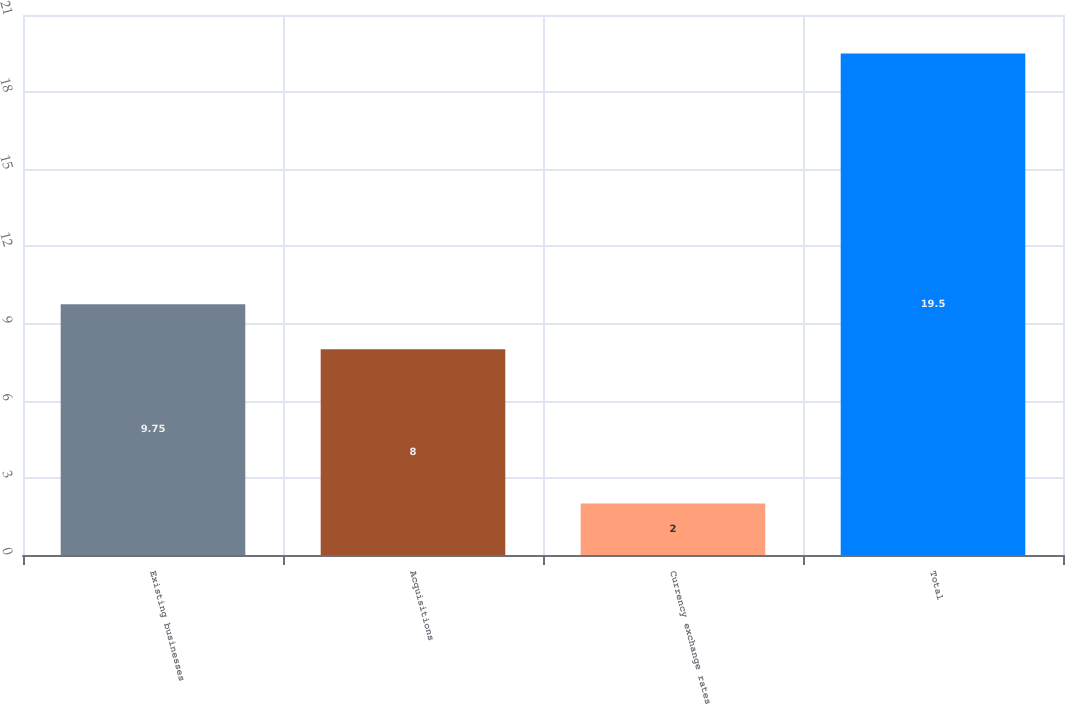Convert chart. <chart><loc_0><loc_0><loc_500><loc_500><bar_chart><fcel>Existing businesses<fcel>Acquisitions<fcel>Currency exchange rates<fcel>Total<nl><fcel>9.75<fcel>8<fcel>2<fcel>19.5<nl></chart> 